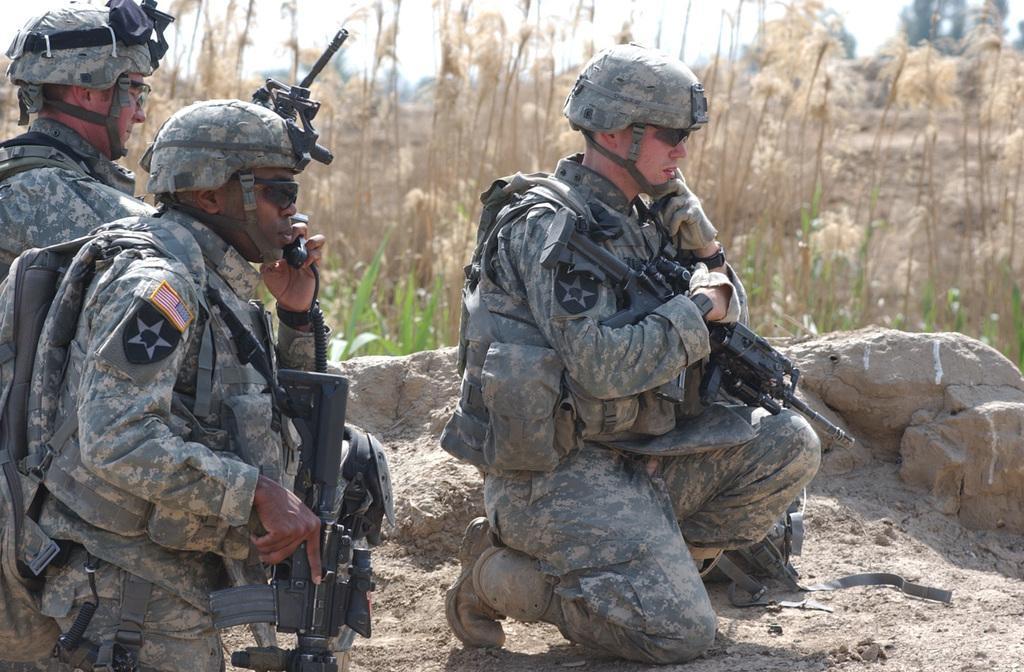How would you summarize this image in a sentence or two? In this picture I can see three persons with helmets and rifles, there are stones, plants, trees, and in the background there is sky. 